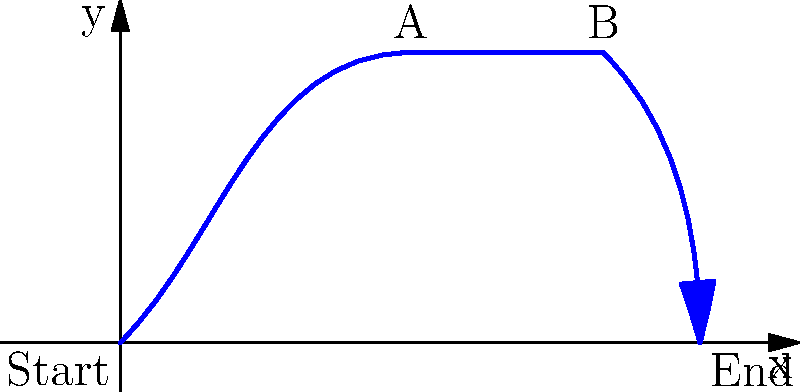In a pivotal chase scene from Breaking Bad, Jesse Pinkman's car follows the path shown in the diagram. If the entire chase lasts 60 seconds and Jesse maintains a constant speed throughout, how many seconds does it take him to travel from point A to point B? To solve this problem, we need to follow these steps:

1. Analyze the path: The path consists of three main segments - a curved path from Start to A, a straight line from A to B, and another curved path from B to End.

2. Calculate the total distance: 
   - Start to A: approximately 4.24 units (diagonal of a 3x3 square)
   - A to B: 2 units (straight line)
   - B to End: approximately 3.16 units (hypotenuse of a 2x3 right triangle)
   - Total distance ≈ 4.24 + 2 + 3.16 = 9.4 units

3. Calculate the proportion of the total distance that A to B represents:
   $\frac{2}{9.4} \approx 0.213$ or about 21.3% of the total distance

4. Since Jesse maintains a constant speed, the time taken is proportional to the distance traveled. If the entire chase takes 60 seconds, then the time to travel from A to B is:

   $60 \times 0.213 \approx 12.8$ seconds

5. Rounding to the nearest second (as it's unlikely the show would be more precise), we get 13 seconds.
Answer: 13 seconds 